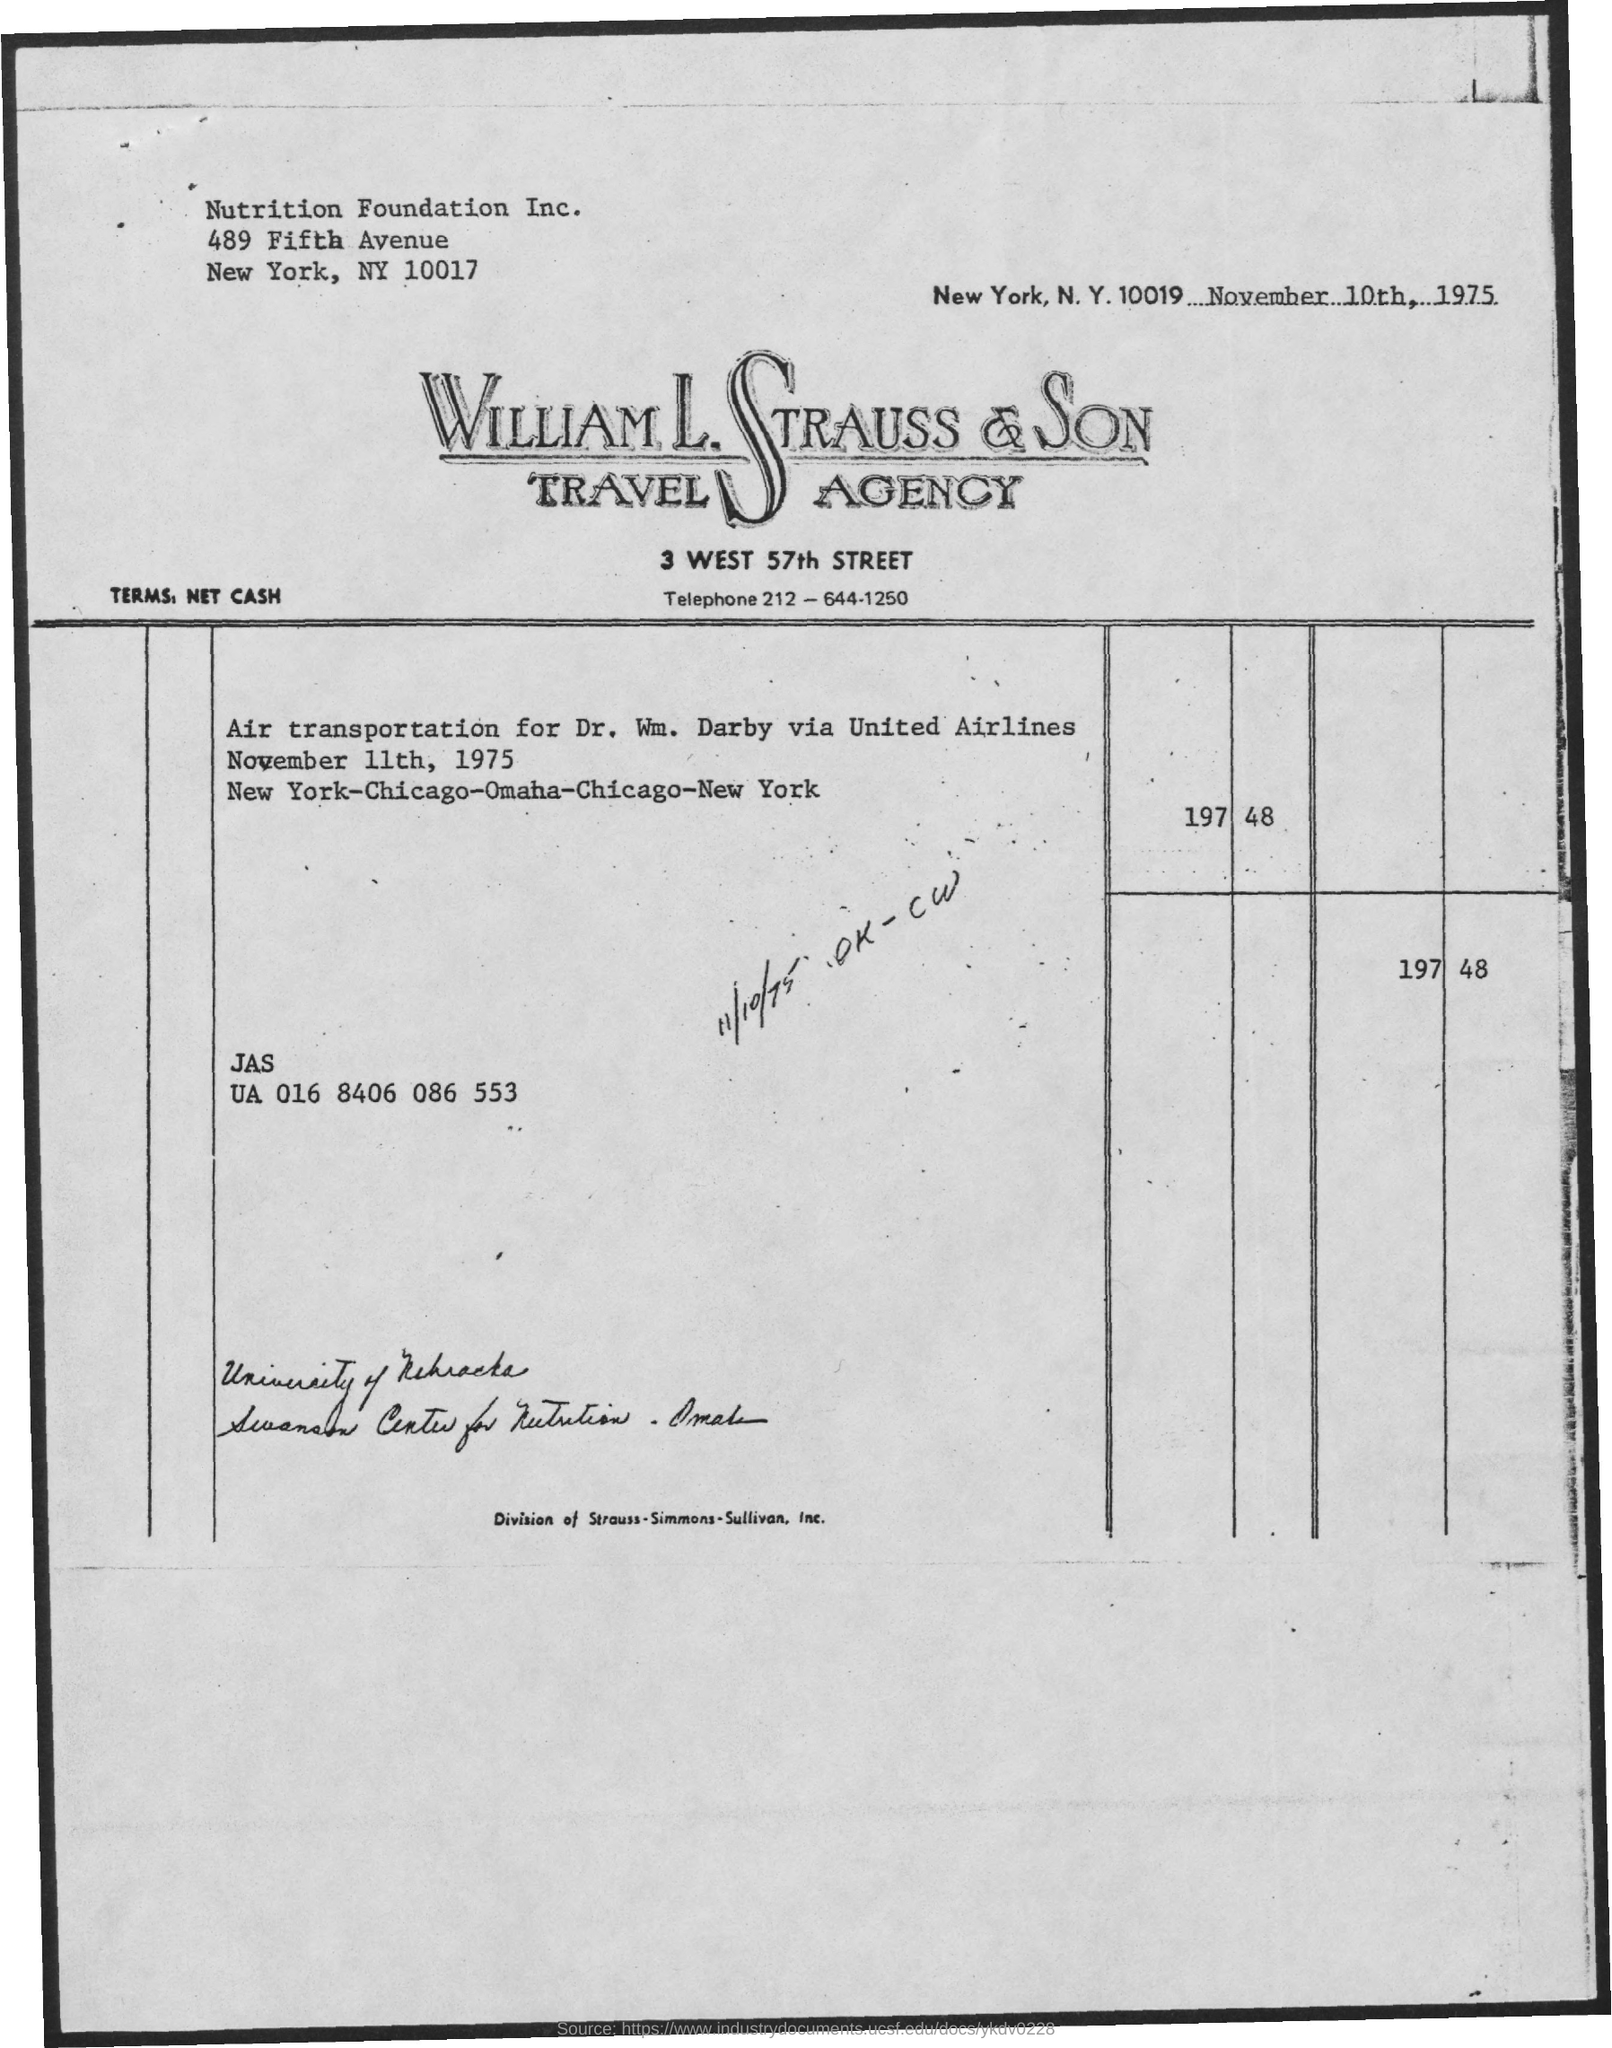Indicate a few pertinent items in this graphic. The memorandum is dated on November 10th, 1975. 